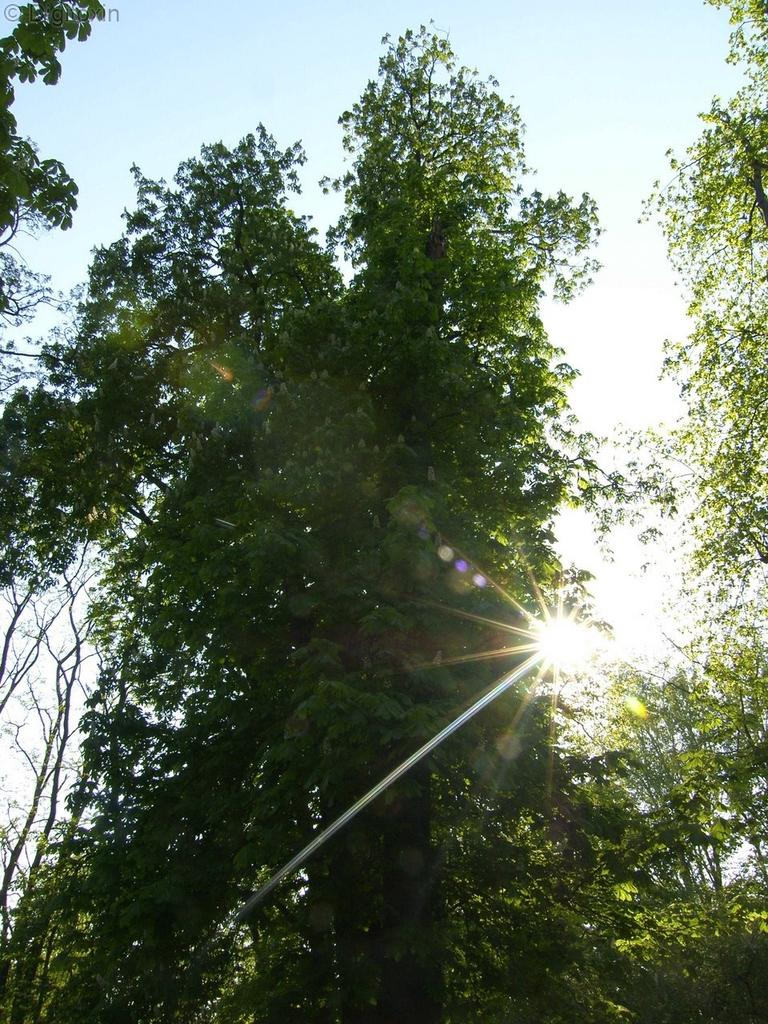What type of vegetation can be seen in the image? There are trees in the image. What is the condition of the sky in the image? The sky is clear in the image. Can you see any corn growing in the image? There is no corn visible in the image; it only features trees. Is there a cherry tree with a red spot on its trunk in the image? There is no cherry tree or any mention of a red spot on a tree trunk in the image. 